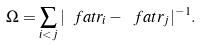<formula> <loc_0><loc_0><loc_500><loc_500>\Omega = \sum _ { i < j } | \ f a t r _ { i } - \ f a t r _ { j } | ^ { - 1 } .</formula> 